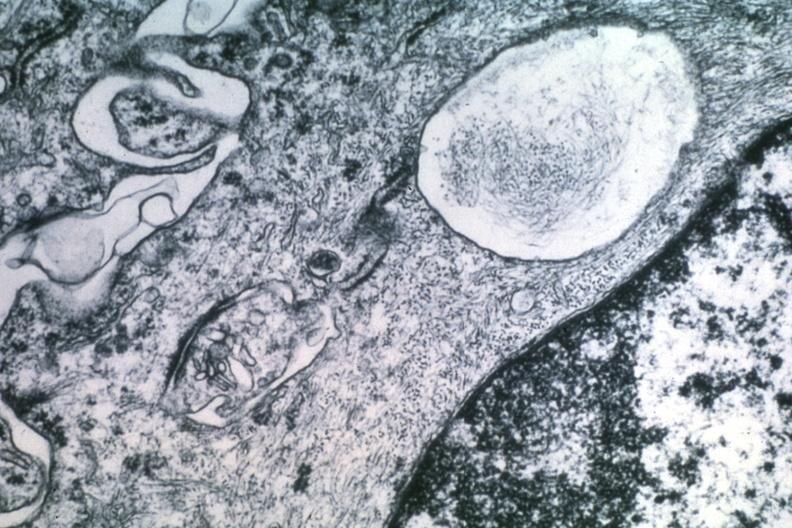what is present?
Answer the question using a single word or phrase. Meningioma 